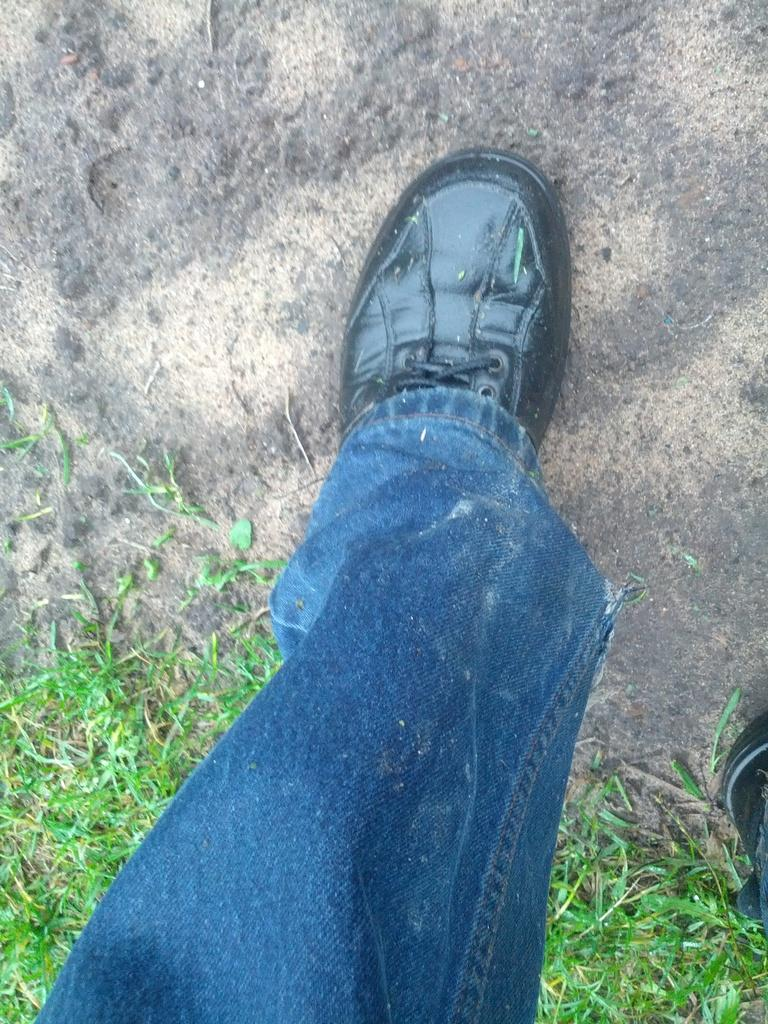What is on the ground in the image? There is a leg of a person on the ground in the image. What type of vegetation can be seen in the image? There is grass visible in the image. What type of breakfast is being served on the leaf in the image? There is no leaf or breakfast present in the image. 